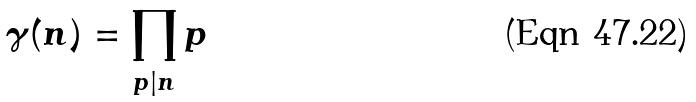Convert formula to latex. <formula><loc_0><loc_0><loc_500><loc_500>\gamma ( n ) = \prod _ { p | n } p</formula> 